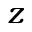Convert formula to latex. <formula><loc_0><loc_0><loc_500><loc_500>z</formula> 